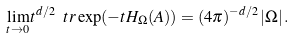<formula> <loc_0><loc_0><loc_500><loc_500>\lim _ { t \to 0 } t ^ { d / 2 } \ t r \exp ( - t H _ { \Omega } ( A ) ) = ( 4 \pi ) ^ { - d / 2 } \, | \Omega | \, .</formula> 